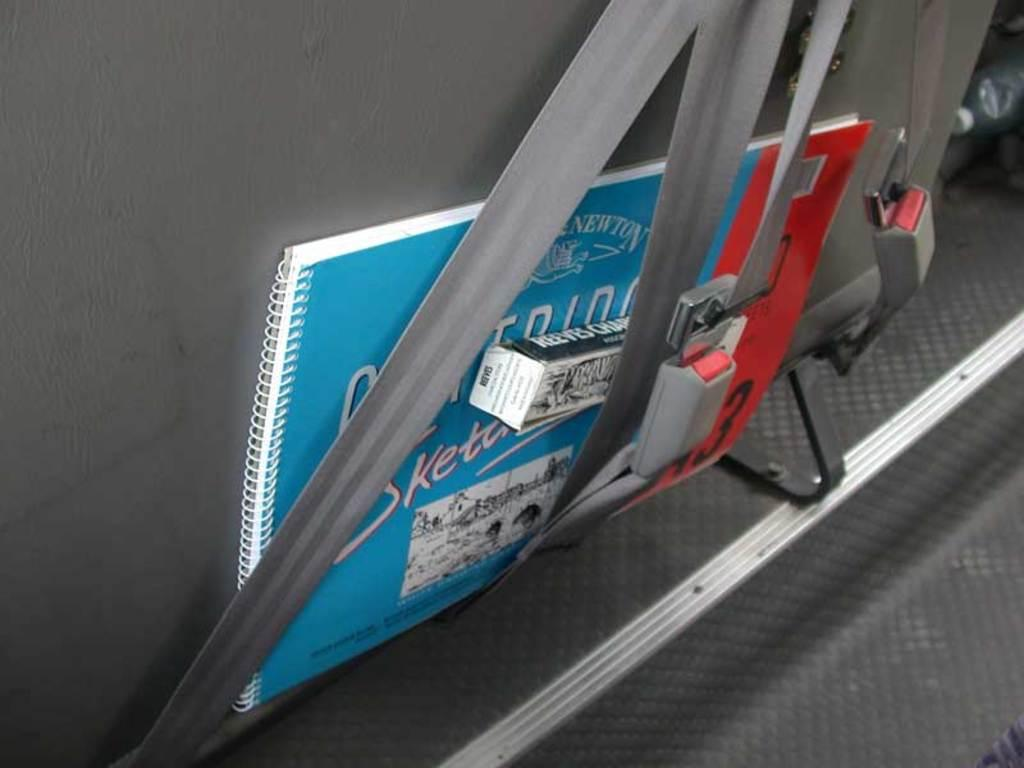What type of vehicle is the seat from in the image? The specific type of vehicle cannot be determined from the image. What safety feature is visible in the image? There are seat belts visible in the image. What items can be seen in the image besides the seat and seat belts? There is a book, a box, and a water bottle present in the image. Where was the image taken? The image was taken inside the vehicle. Is there a rabbit sitting on the book in the image? No, there is no rabbit present in the image. What type of fruit is being peeled in the image? There is no fruit, including a banana, present in the image. 